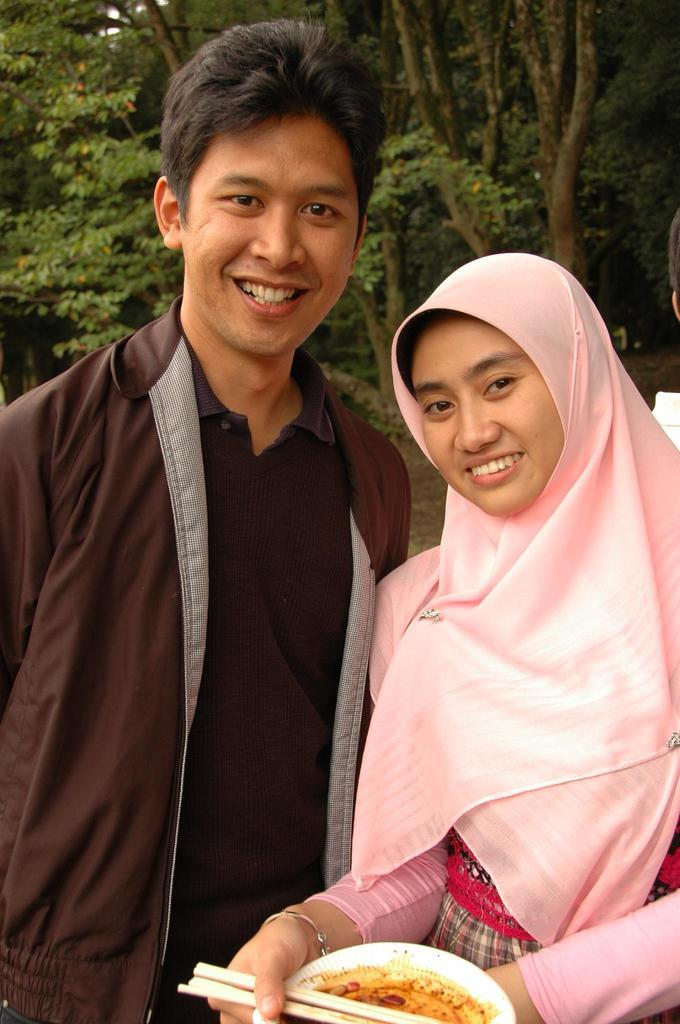How many people are present in the image? There are two people in the image. Can you describe the gender of the people in the image? One of the people is a man, and the other person is a woman. What is the woman holding in her hand? The woman is holding a food plate in her hand. How many hours of sleep did the man get last night, as depicted in the image? The image does not provide any information about the man's sleep, so it cannot be determined from the image. What type of prose is the woman reading from the food plate in the image? There is no indication in the image that the woman is reading any prose, as she is holding a food plate, not a book or any written material. 